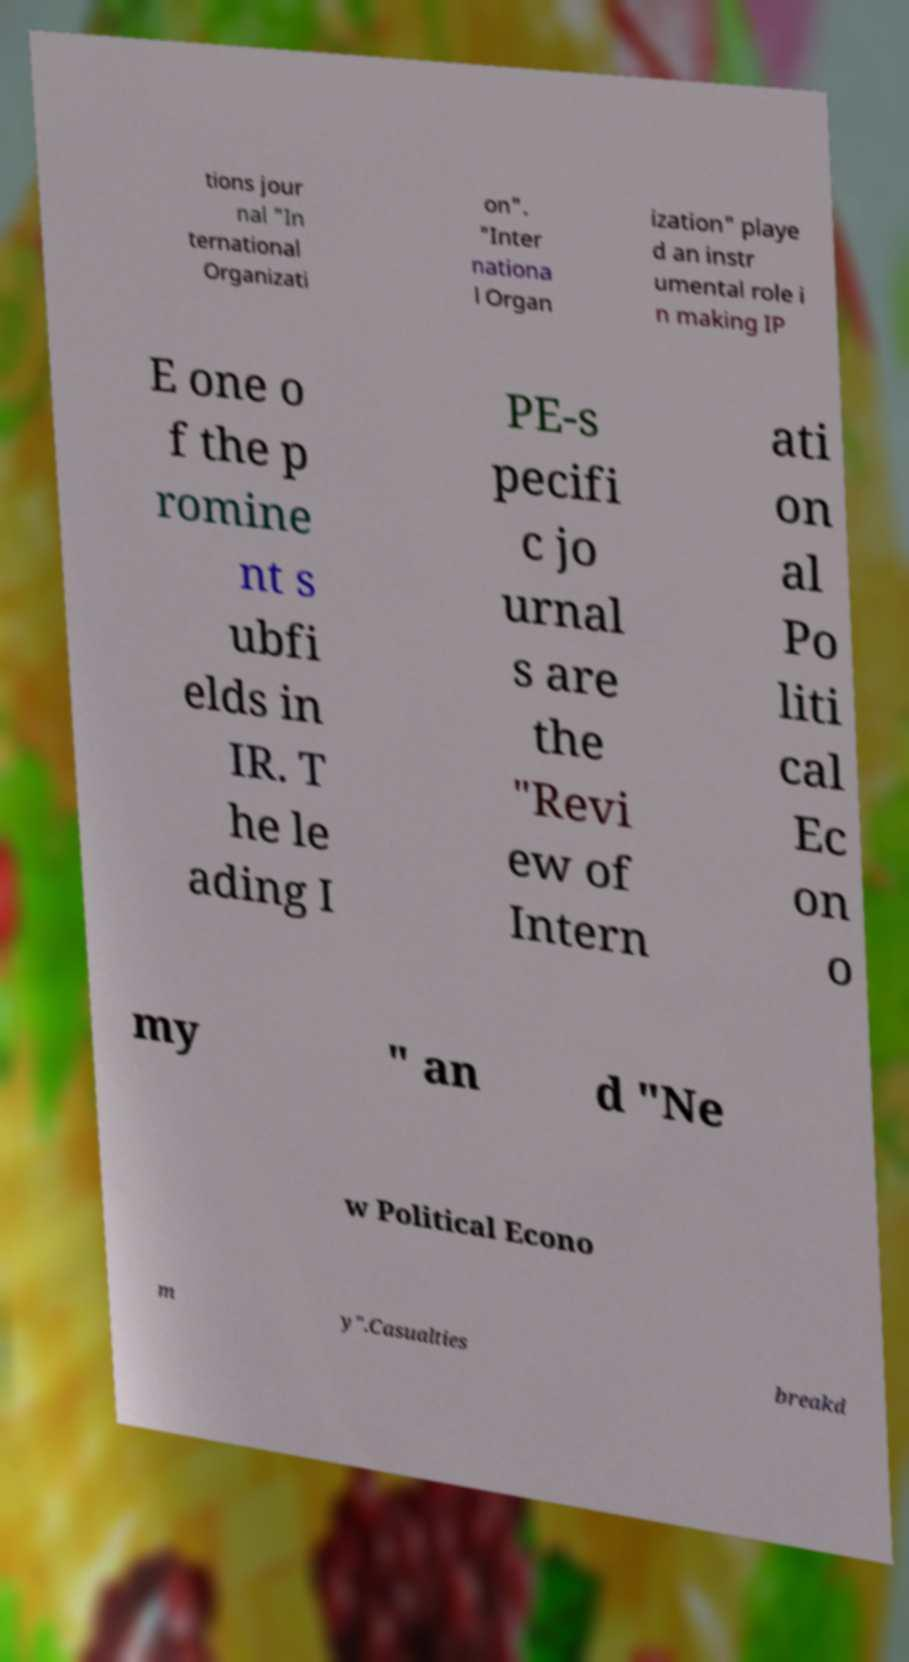What messages or text are displayed in this image? I need them in a readable, typed format. tions jour nal "In ternational Organizati on". "Inter nationa l Organ ization" playe d an instr umental role i n making IP E one o f the p romine nt s ubfi elds in IR. T he le ading I PE-s pecifi c jo urnal s are the "Revi ew of Intern ati on al Po liti cal Ec on o my " an d "Ne w Political Econo m y".Casualties breakd 